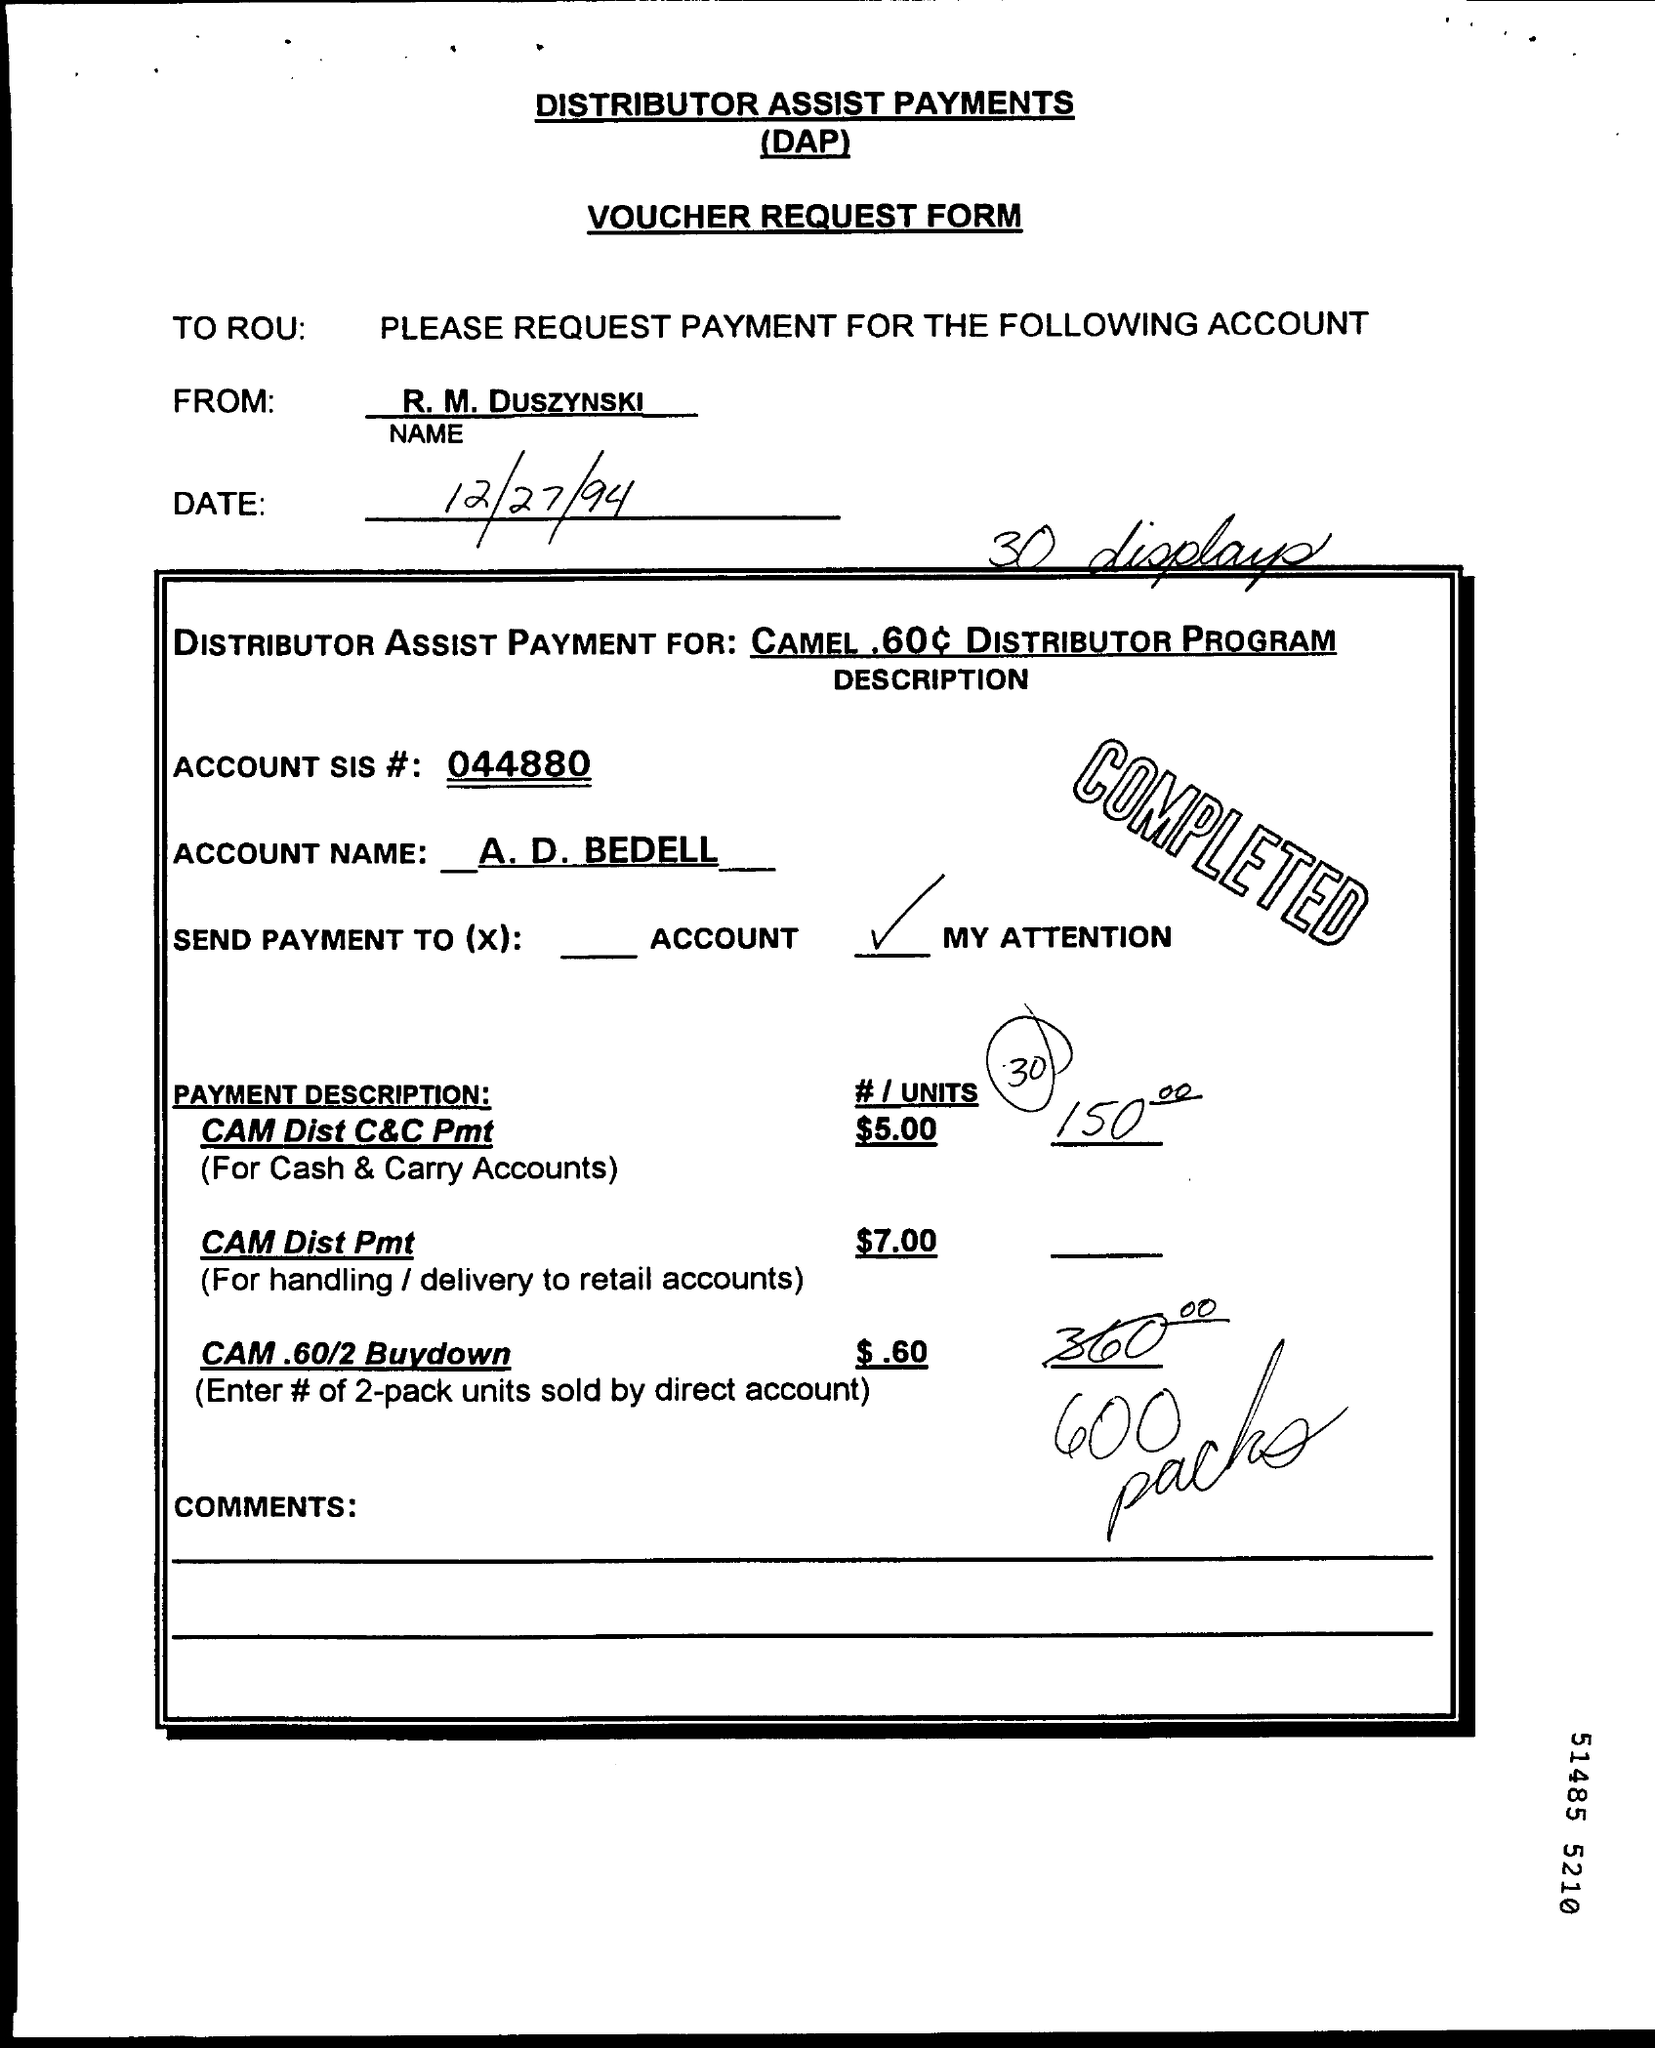Outline some significant characteristics in this image. The date printed on the document is December 27, 1994. 